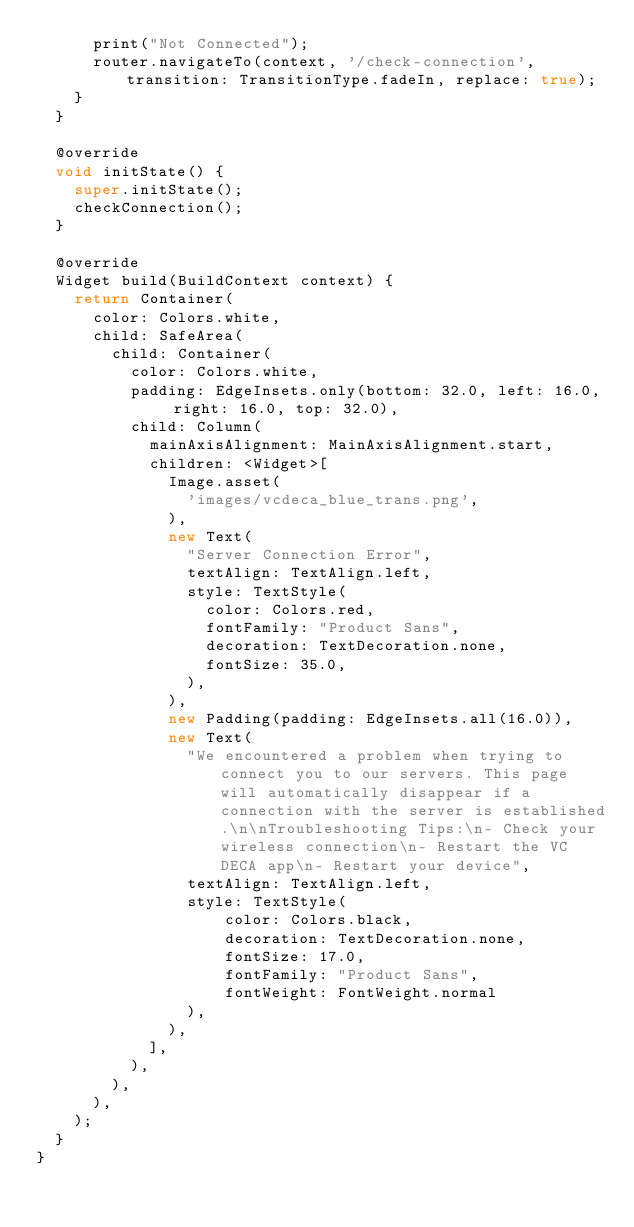<code> <loc_0><loc_0><loc_500><loc_500><_Dart_>      print("Not Connected");
      router.navigateTo(context, '/check-connection', transition: TransitionType.fadeIn, replace: true);
    }
  }

  @override
  void initState() {
    super.initState();
    checkConnection();
  }

  @override
  Widget build(BuildContext context) {
    return Container(
      color: Colors.white,
      child: SafeArea(
        child: Container(
          color: Colors.white,
          padding: EdgeInsets.only(bottom: 32.0, left: 16.0, right: 16.0, top: 32.0),
          child: Column(
            mainAxisAlignment: MainAxisAlignment.start,
            children: <Widget>[
              Image.asset(
                'images/vcdeca_blue_trans.png',
              ),
              new Text(
                "Server Connection Error",
                textAlign: TextAlign.left,
                style: TextStyle(
                  color: Colors.red,
                  fontFamily: "Product Sans",
                  decoration: TextDecoration.none,
                  fontSize: 35.0,
                ),
              ),
              new Padding(padding: EdgeInsets.all(16.0)),
              new Text(
                "We encountered a problem when trying to connect you to our servers. This page will automatically disappear if a connection with the server is established.\n\nTroubleshooting Tips:\n- Check your wireless connection\n- Restart the VC DECA app\n- Restart your device",
                textAlign: TextAlign.left,
                style: TextStyle(
                    color: Colors.black,
                    decoration: TextDecoration.none,
                    fontSize: 17.0,
                    fontFamily: "Product Sans",
                    fontWeight: FontWeight.normal
                ),
              ),
            ],
          ),
        ),
      ),
    );
  }
}
</code> 